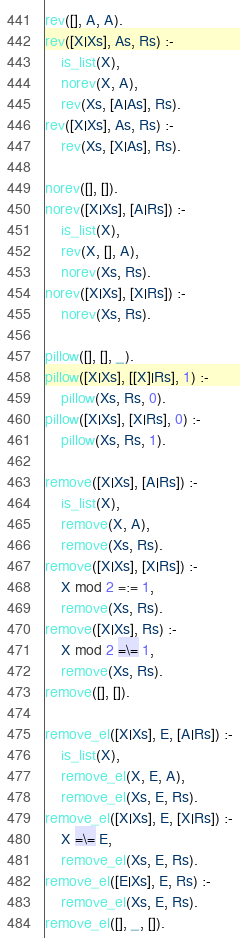<code> <loc_0><loc_0><loc_500><loc_500><_Prolog_>rev([], A, A).
rev([X|Xs], As, Rs) :-
    is_list(X),
    norev(X, A),
    rev(Xs, [A|As], Rs).
rev([X|Xs], As, Rs) :-
    rev(Xs, [X|As], Rs).

norev([], []).
norev([X|Xs], [A|Rs]) :-
    is_list(X),
    rev(X, [], A),
    norev(Xs, Rs).
norev([X|Xs], [X|Rs]) :-
    norev(Xs, Rs).

pillow([], [], _).
pillow([X|Xs], [[X]|Rs], 1) :-
    pillow(Xs, Rs, 0).
pillow([X|Xs], [X|Rs], 0) :-
    pillow(Xs, Rs, 1).

remove([X|Xs], [A|Rs]) :-
    is_list(X),
    remove(X, A),
    remove(Xs, Rs).
remove([X|Xs], [X|Rs]) :-
    X mod 2 =:= 1,
    remove(Xs, Rs).
remove([X|Xs], Rs) :-
    X mod 2 =\= 1,
    remove(Xs, Rs).
remove([], []).

remove_el([X|Xs], E, [A|Rs]) :-
    is_list(X),
    remove_el(X, E, A),
    remove_el(Xs, E, Rs).
remove_el([X|Xs], E, [X|Rs]) :-
    X =\= E,
    remove_el(Xs, E, Rs).
remove_el([E|Xs], E, Rs) :-
    remove_el(Xs, E, Rs).
remove_el([], _, []).
</code> 